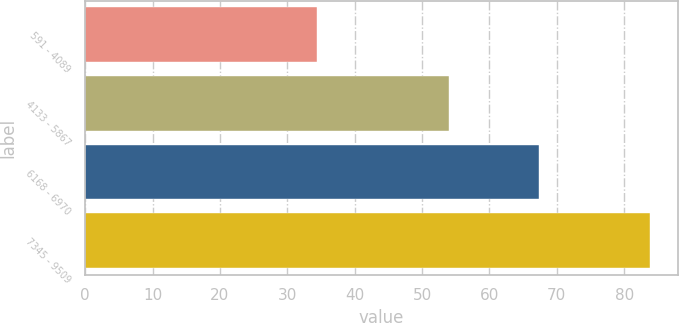Convert chart to OTSL. <chart><loc_0><loc_0><loc_500><loc_500><bar_chart><fcel>591 - 4089<fcel>4133 - 5867<fcel>6168 - 6970<fcel>7345 - 9509<nl><fcel>34.39<fcel>54.02<fcel>67.38<fcel>83.78<nl></chart> 